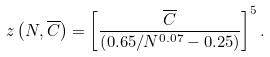<formula> <loc_0><loc_0><loc_500><loc_500>z \left ( N , \overline { C } \right ) = \left [ \frac { \overline { C } } { \left ( 0 . 6 5 / N ^ { 0 . 0 7 } - 0 . 2 5 \right ) } \right ] ^ { 5 } .</formula> 